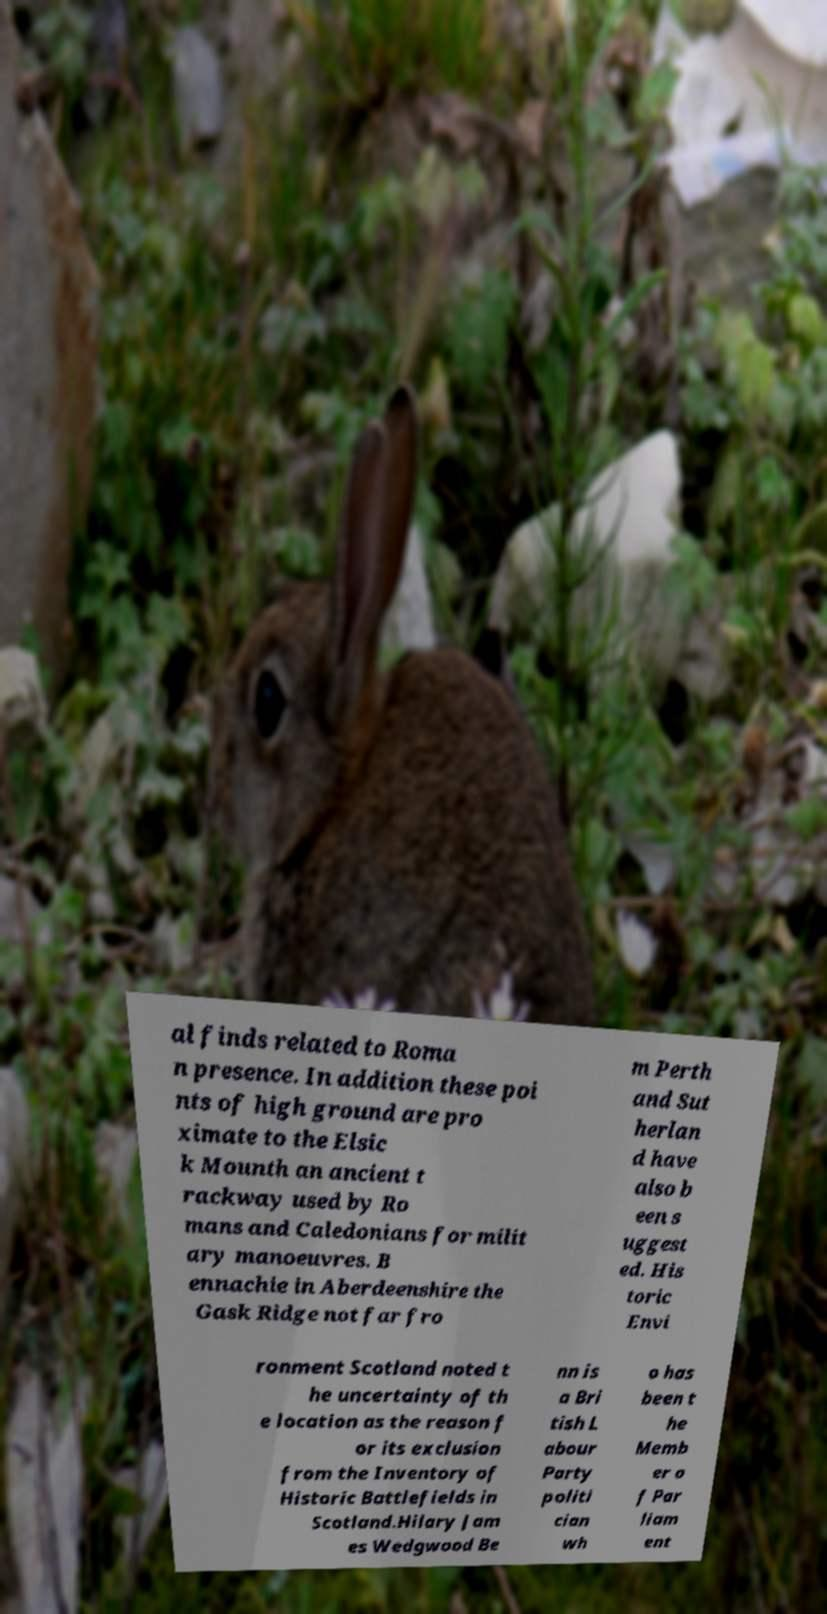Could you assist in decoding the text presented in this image and type it out clearly? al finds related to Roma n presence. In addition these poi nts of high ground are pro ximate to the Elsic k Mounth an ancient t rackway used by Ro mans and Caledonians for milit ary manoeuvres. B ennachie in Aberdeenshire the Gask Ridge not far fro m Perth and Sut herlan d have also b een s uggest ed. His toric Envi ronment Scotland noted t he uncertainty of th e location as the reason f or its exclusion from the Inventory of Historic Battlefields in Scotland.Hilary Jam es Wedgwood Be nn is a Bri tish L abour Party politi cian wh o has been t he Memb er o f Par liam ent 